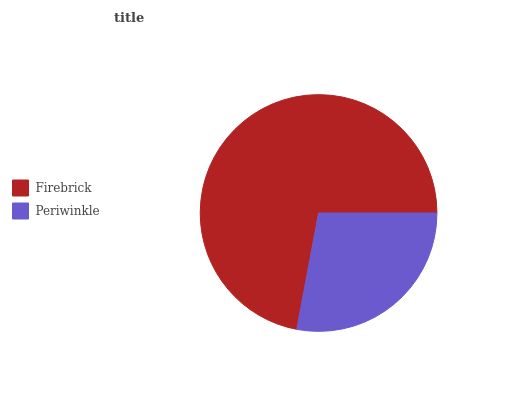Is Periwinkle the minimum?
Answer yes or no. Yes. Is Firebrick the maximum?
Answer yes or no. Yes. Is Periwinkle the maximum?
Answer yes or no. No. Is Firebrick greater than Periwinkle?
Answer yes or no. Yes. Is Periwinkle less than Firebrick?
Answer yes or no. Yes. Is Periwinkle greater than Firebrick?
Answer yes or no. No. Is Firebrick less than Periwinkle?
Answer yes or no. No. Is Firebrick the high median?
Answer yes or no. Yes. Is Periwinkle the low median?
Answer yes or no. Yes. Is Periwinkle the high median?
Answer yes or no. No. Is Firebrick the low median?
Answer yes or no. No. 